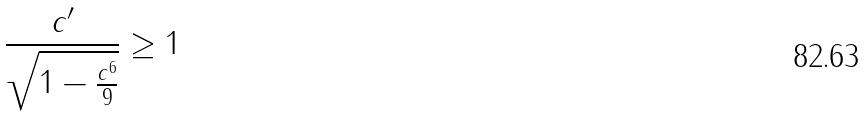<formula> <loc_0><loc_0><loc_500><loc_500>\frac { c ^ { \prime } } { \sqrt { 1 - \frac { c ^ { 6 } } { 9 } } } \geq 1</formula> 